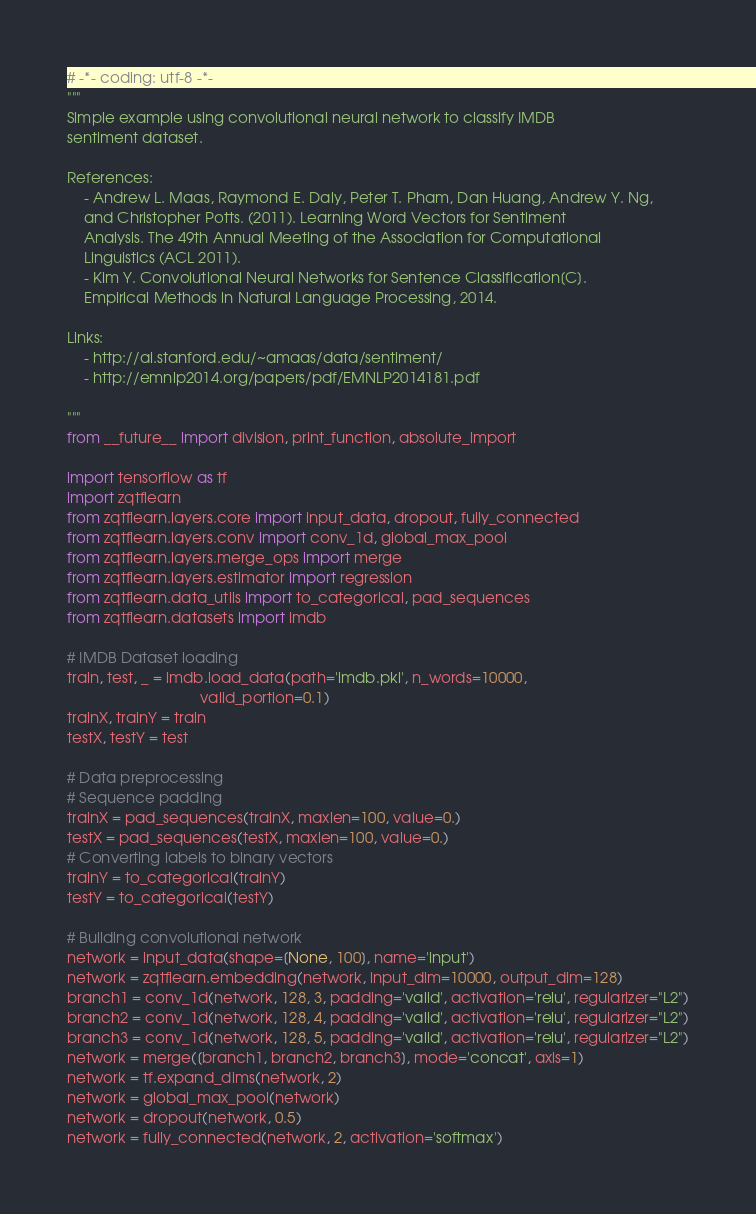Convert code to text. <code><loc_0><loc_0><loc_500><loc_500><_Python_># -*- coding: utf-8 -*-
"""
Simple example using convolutional neural network to classify IMDB
sentiment dataset.

References:
    - Andrew L. Maas, Raymond E. Daly, Peter T. Pham, Dan Huang, Andrew Y. Ng,
    and Christopher Potts. (2011). Learning Word Vectors for Sentiment
    Analysis. The 49th Annual Meeting of the Association for Computational
    Linguistics (ACL 2011).
    - Kim Y. Convolutional Neural Networks for Sentence Classification[C]. 
    Empirical Methods in Natural Language Processing, 2014.

Links:
    - http://ai.stanford.edu/~amaas/data/sentiment/
    - http://emnlp2014.org/papers/pdf/EMNLP2014181.pdf

"""
from __future__ import division, print_function, absolute_import

import tensorflow as tf
import zqtflearn
from zqtflearn.layers.core import input_data, dropout, fully_connected
from zqtflearn.layers.conv import conv_1d, global_max_pool
from zqtflearn.layers.merge_ops import merge
from zqtflearn.layers.estimator import regression
from zqtflearn.data_utils import to_categorical, pad_sequences
from zqtflearn.datasets import imdb

# IMDB Dataset loading
train, test, _ = imdb.load_data(path='imdb.pkl', n_words=10000,
                                valid_portion=0.1)
trainX, trainY = train
testX, testY = test

# Data preprocessing
# Sequence padding
trainX = pad_sequences(trainX, maxlen=100, value=0.)
testX = pad_sequences(testX, maxlen=100, value=0.)
# Converting labels to binary vectors
trainY = to_categorical(trainY)
testY = to_categorical(testY)

# Building convolutional network
network = input_data(shape=[None, 100], name='input')
network = zqtflearn.embedding(network, input_dim=10000, output_dim=128)
branch1 = conv_1d(network, 128, 3, padding='valid', activation='relu', regularizer="L2")
branch2 = conv_1d(network, 128, 4, padding='valid', activation='relu', regularizer="L2")
branch3 = conv_1d(network, 128, 5, padding='valid', activation='relu', regularizer="L2")
network = merge([branch1, branch2, branch3], mode='concat', axis=1)
network = tf.expand_dims(network, 2)
network = global_max_pool(network)
network = dropout(network, 0.5)
network = fully_connected(network, 2, activation='softmax')</code> 